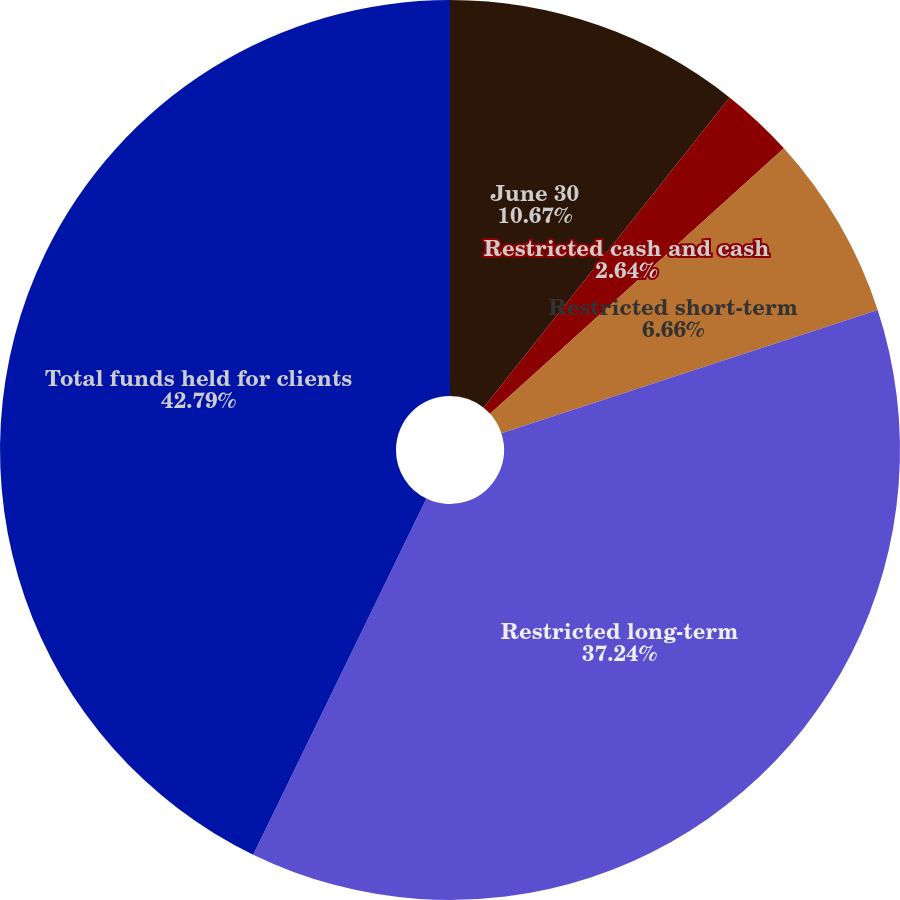<chart> <loc_0><loc_0><loc_500><loc_500><pie_chart><fcel>June 30<fcel>Restricted cash and cash<fcel>Restricted short-term<fcel>Restricted long-term<fcel>Total funds held for clients<nl><fcel>10.67%<fcel>2.64%<fcel>6.66%<fcel>37.24%<fcel>42.8%<nl></chart> 